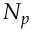<formula> <loc_0><loc_0><loc_500><loc_500>N _ { p }</formula> 